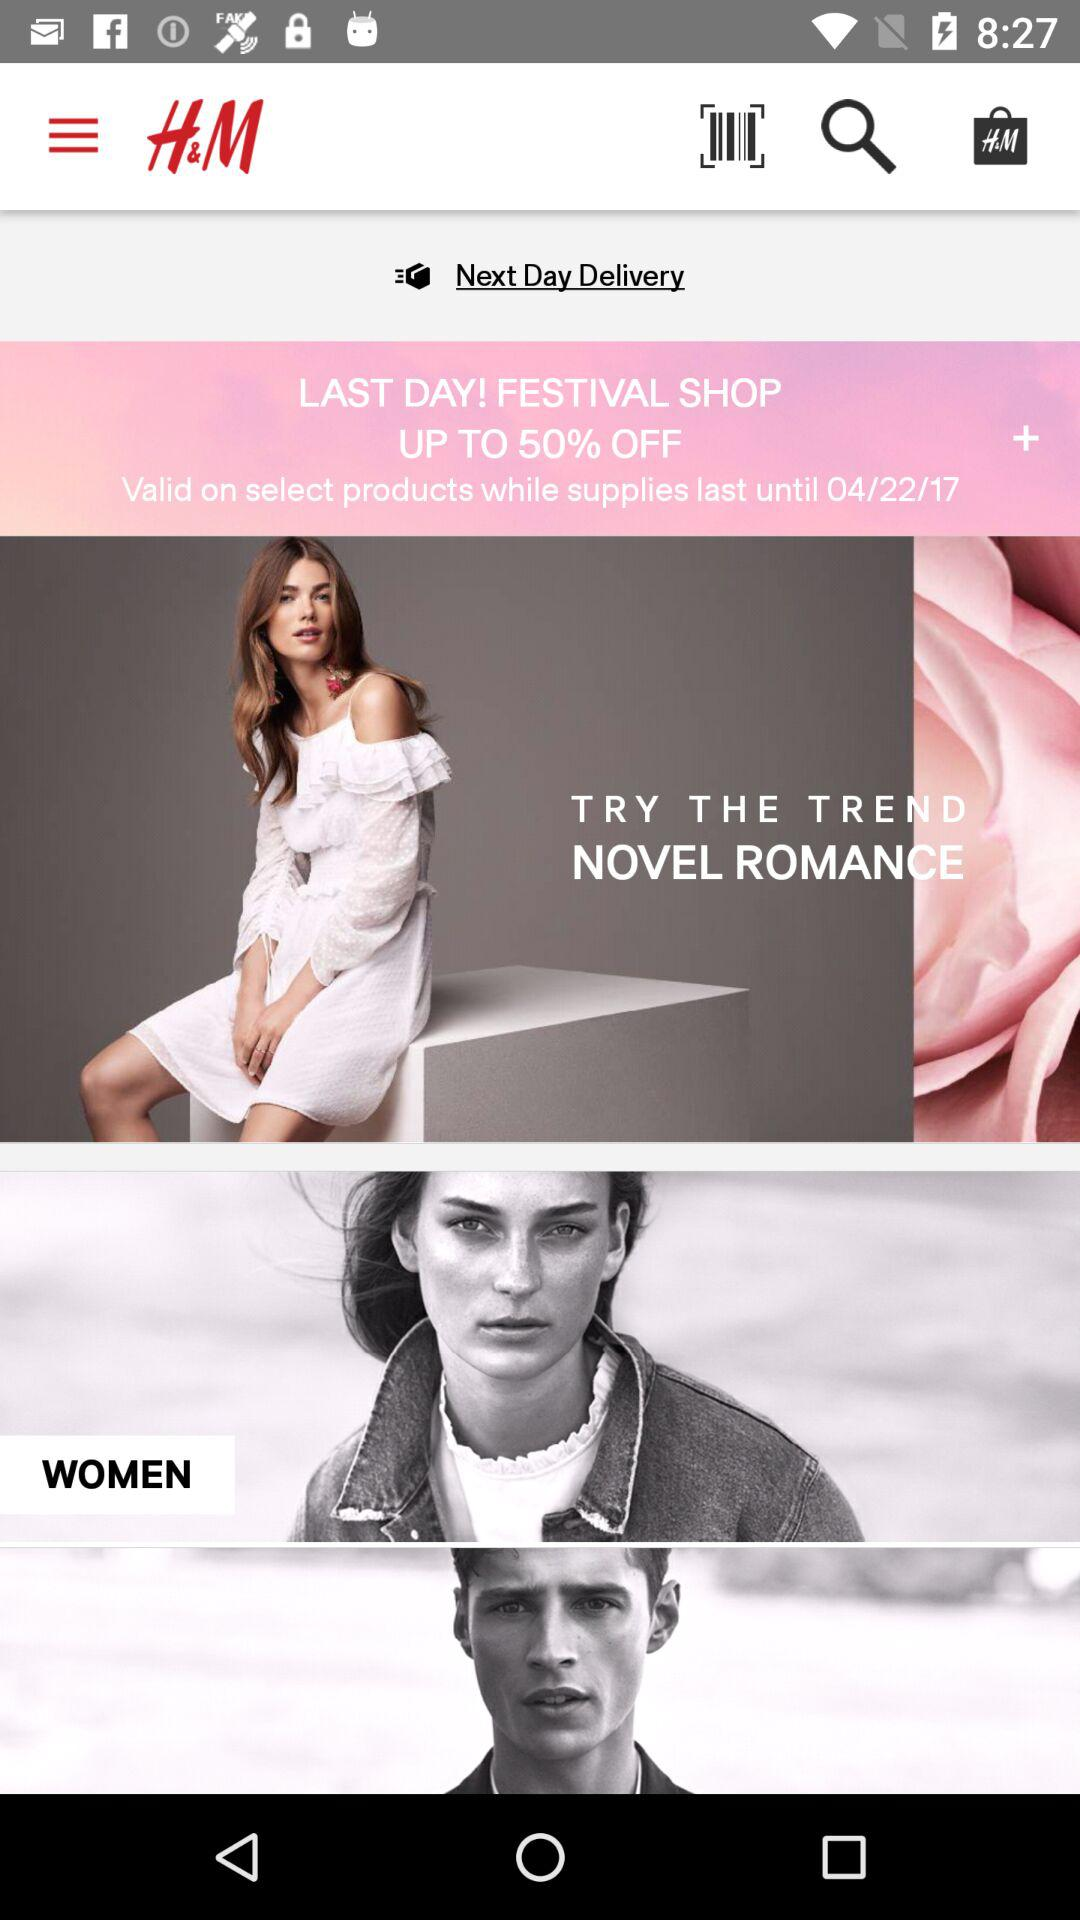How much of a discount is available at the Last Day Festival Shop? The discount is up to 50% off. 